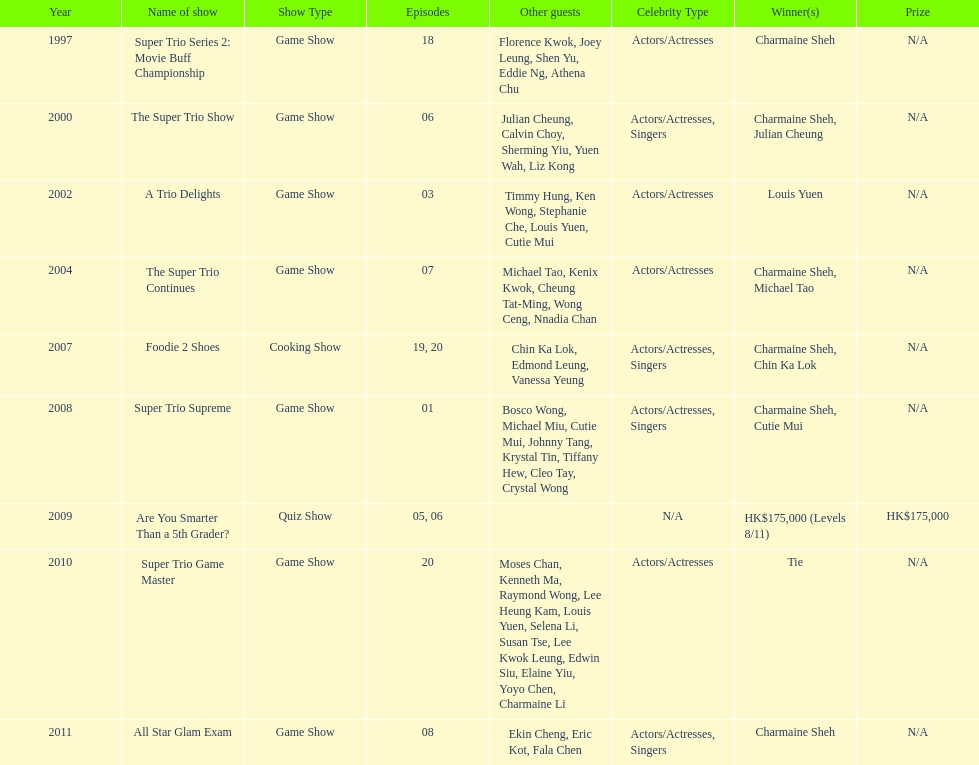What year was the only year were a tie occurred? 2010. 